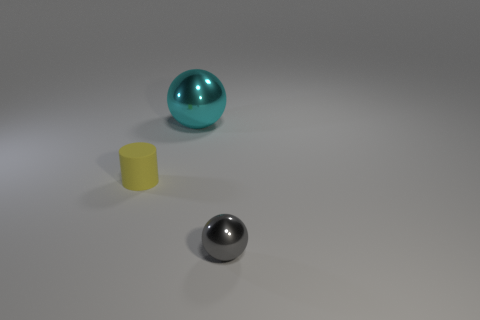Is there any other thing that is the same material as the yellow cylinder?
Provide a short and direct response. No. Do the rubber object and the sphere that is behind the tiny yellow matte object have the same size?
Your response must be concise. No. Are there any brown metal cylinders?
Offer a very short reply. No. Do the shiny object that is behind the small yellow rubber cylinder and the ball that is in front of the small yellow matte thing have the same size?
Offer a very short reply. No. There is a thing that is on the right side of the cylinder and in front of the large cyan sphere; what material is it?
Your answer should be very brief. Metal. How many tiny gray objects are to the left of the big thing?
Your answer should be very brief. 0. Is there anything else that has the same size as the cyan ball?
Provide a short and direct response. No. What color is the big thing that is the same material as the tiny gray sphere?
Give a very brief answer. Cyan. Do the tiny metal thing and the large cyan object have the same shape?
Give a very brief answer. Yes. What number of objects are both to the right of the matte cylinder and behind the gray shiny thing?
Your answer should be compact. 1. 